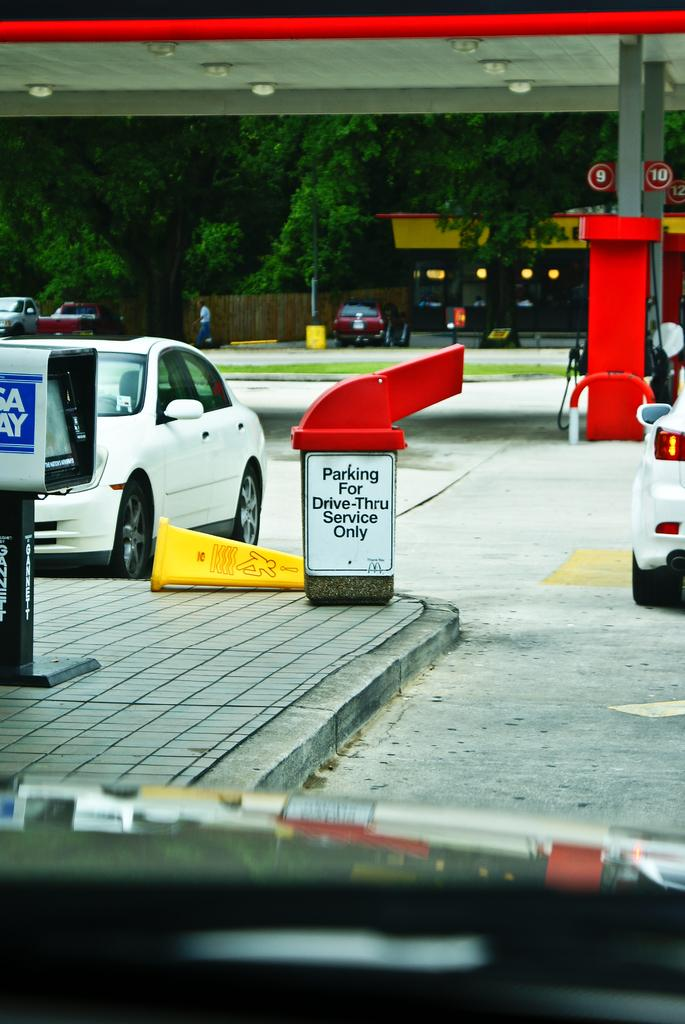<image>
Present a compact description of the photo's key features. a trash can that says parking on it 